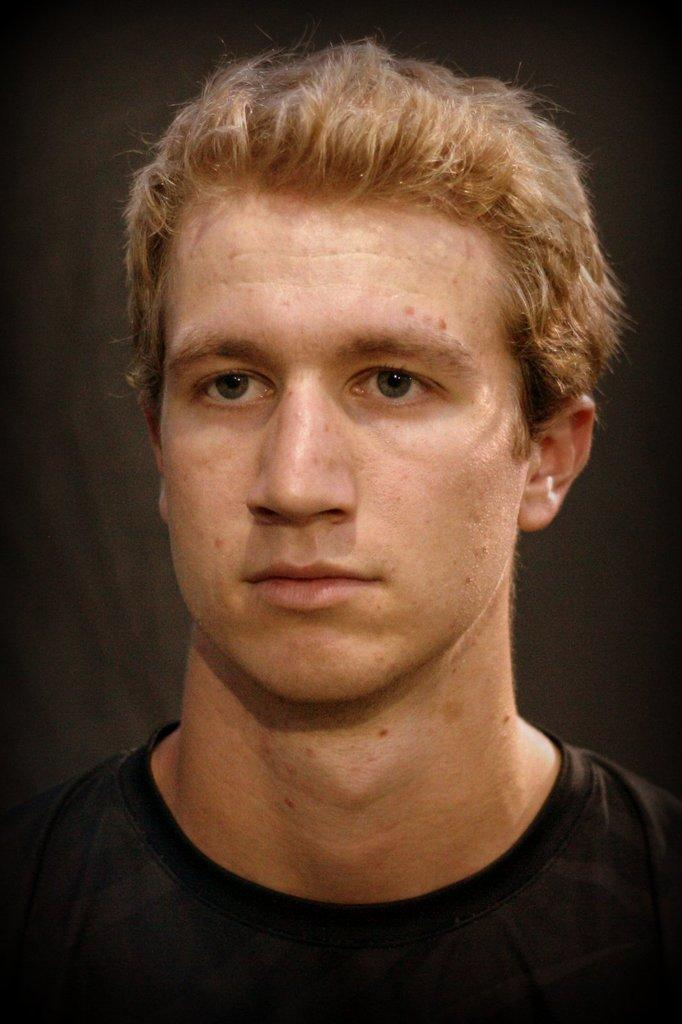What is present in the image? There is a man in the image. What is the man wearing? The man is wearing a black T-shirt. What type of steel is the kitty playing with in the image? There is no kitty or steel present in the image; it only features a man wearing a black T-shirt. 